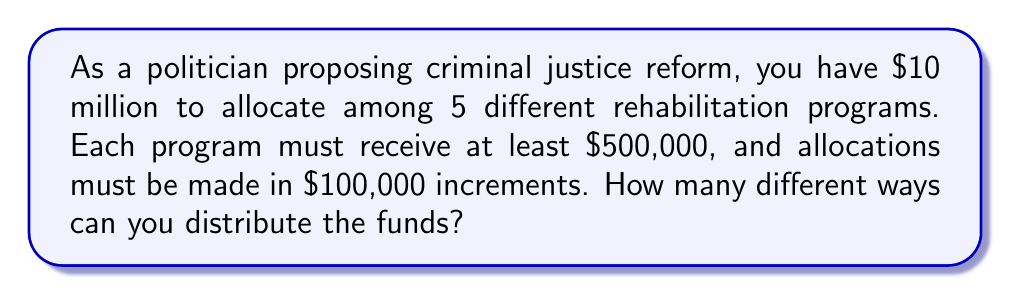Can you solve this math problem? Let's approach this step-by-step:

1) First, we need to consider the constraints:
   - Total budget: $10 million
   - Minimum allocation per program: $500,000
   - Allocation increment: $100,000

2) Let's allocate the minimum amount to each program:
   $500,000 × 5 programs = $2,500,000

3) Remaining amount to be distributed:
   $10,000,000 - $2,500,000 = $7,500,000

4) Number of $100,000 increments in the remaining amount:
   $7,500,000 ÷ $100,000 = 75 increments

5) Now, we need to distribute these 75 increments among 5 programs.

6) This is a classic stars and bars problem. The formula for distributing n indistinguishable objects into k distinguishable boxes is:

   $$\binom{n+k-1}{k-1}$$

7) In our case, n = 75 (increments) and k = 5 (programs). So we need to calculate:

   $$\binom{75+5-1}{5-1} = \binom{79}{4}$$

8) This can be calculated as:

   $$\binom{79}{4} = \frac{79!}{4!(79-4)!} = \frac{79!}{4!75!}$$

9) Simplifying:
   $$\frac{79 × 78 × 77 × 76}{4 × 3 × 2 × 1} = 1,502,501$$

Therefore, there are 1,502,501 different ways to distribute the funds.
Answer: 1,502,501 